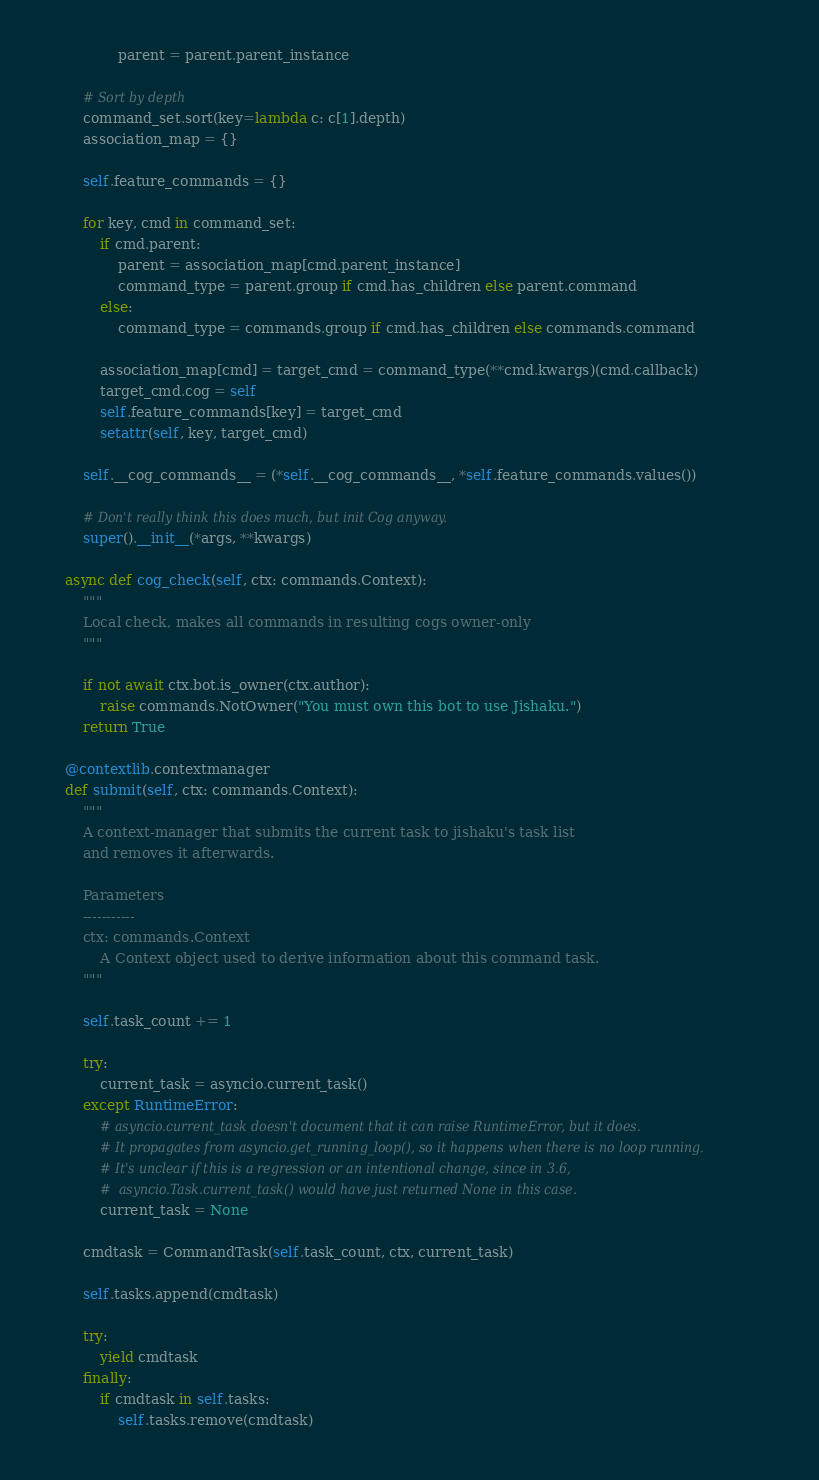Convert code to text. <code><loc_0><loc_0><loc_500><loc_500><_Python_>                parent = parent.parent_instance

        # Sort by depth
        command_set.sort(key=lambda c: c[1].depth)
        association_map = {}

        self.feature_commands = {}

        for key, cmd in command_set:
            if cmd.parent:
                parent = association_map[cmd.parent_instance]
                command_type = parent.group if cmd.has_children else parent.command
            else:
                command_type = commands.group if cmd.has_children else commands.command

            association_map[cmd] = target_cmd = command_type(**cmd.kwargs)(cmd.callback)
            target_cmd.cog = self
            self.feature_commands[key] = target_cmd
            setattr(self, key, target_cmd)

        self.__cog_commands__ = (*self.__cog_commands__, *self.feature_commands.values())

        # Don't really think this does much, but init Cog anyway.
        super().__init__(*args, **kwargs)

    async def cog_check(self, ctx: commands.Context):
        """
        Local check, makes all commands in resulting cogs owner-only
        """

        if not await ctx.bot.is_owner(ctx.author):
            raise commands.NotOwner("You must own this bot to use Jishaku.")
        return True

    @contextlib.contextmanager
    def submit(self, ctx: commands.Context):
        """
        A context-manager that submits the current task to jishaku's task list
        and removes it afterwards.

        Parameters
        -----------
        ctx: commands.Context
            A Context object used to derive information about this command task.
        """

        self.task_count += 1

        try:
            current_task = asyncio.current_task()
        except RuntimeError:
            # asyncio.current_task doesn't document that it can raise RuntimeError, but it does.
            # It propagates from asyncio.get_running_loop(), so it happens when there is no loop running.
            # It's unclear if this is a regression or an intentional change, since in 3.6,
            #  asyncio.Task.current_task() would have just returned None in this case.
            current_task = None

        cmdtask = CommandTask(self.task_count, ctx, current_task)

        self.tasks.append(cmdtask)

        try:
            yield cmdtask
        finally:
            if cmdtask in self.tasks:
                self.tasks.remove(cmdtask)
</code> 